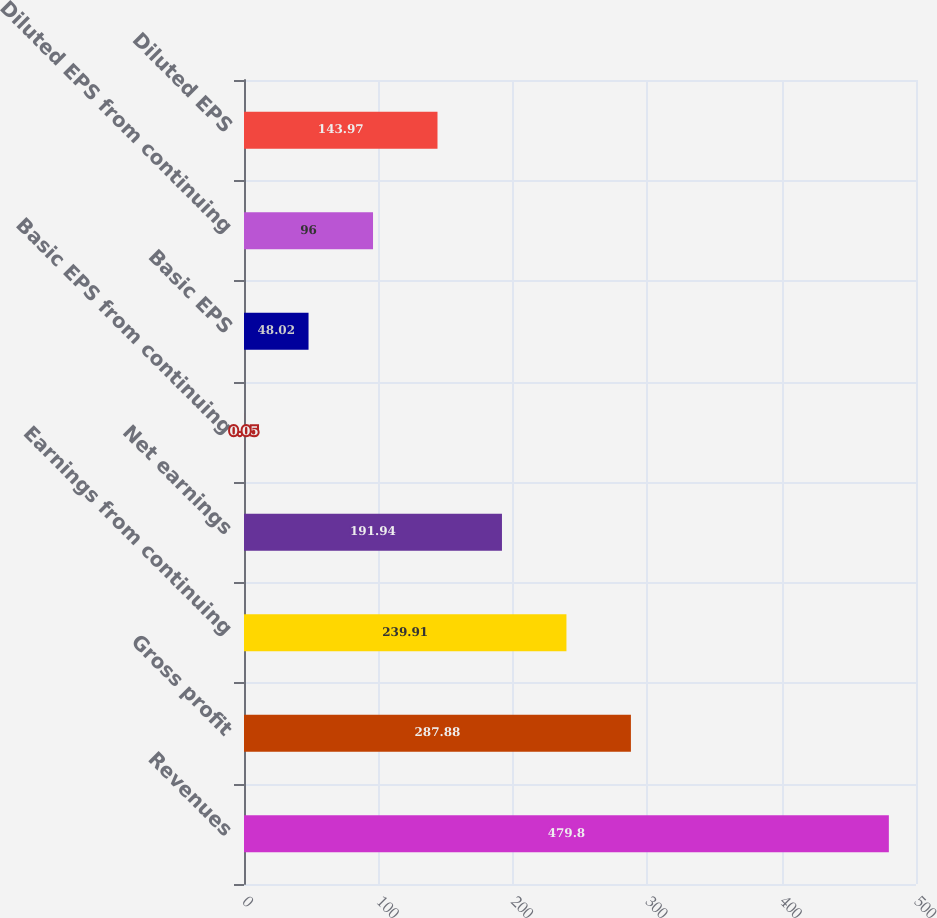<chart> <loc_0><loc_0><loc_500><loc_500><bar_chart><fcel>Revenues<fcel>Gross profit<fcel>Earnings from continuing<fcel>Net earnings<fcel>Basic EPS from continuing<fcel>Basic EPS<fcel>Diluted EPS from continuing<fcel>Diluted EPS<nl><fcel>479.8<fcel>287.88<fcel>239.91<fcel>191.94<fcel>0.05<fcel>48.02<fcel>96<fcel>143.97<nl></chart> 